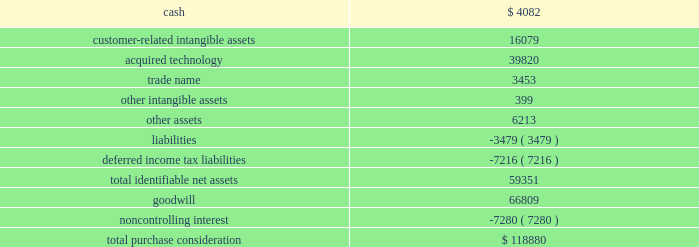Strategy to provide omni-channel solutions that combine gateway services , payment service provisioning and merchant acquiring across europe .
This transaction was accounted for as a business combination .
We recorded the assets acquired , liabilities assumed and noncontrolling interest at their estimated fair values as of the acquisition date .
In connection with the acquisition of realex , we paid a transaction-related tax of $ 1.2 million .
Other acquisition costs were not material .
The revenue and earnings of realex for the year ended may 31 , 2015 were not material nor were the historical revenue and earnings of realex material for the purpose of presenting pro forma information for the current or prior-year periods .
The estimated acquisition date fair values of the assets acquired , liabilities assumed and the noncontrolling interest , including a reconciliation to the total purchase consideration , are as follows ( in thousands ) : .
Goodwill of $ 66.8 million arising from the acquisition , included in the europe segment , was attributable to expected growth opportunities in europe , potential synergies from combining our existing business with gateway services and payment service provisioning in certain markets and an assembled workforce to support the newly acquired technology .
Goodwill associated with this acquisition is not deductible for income tax purposes .
The customer-related intangible assets have an estimated amortization period of 16 years .
The acquired technology has an estimated amortization period of 10 years .
The trade name has an estimated amortization period of 7 years .
On october 5 , 2015 , we paid 20ac6.7 million ( $ 7.5 million equivalent as of october 5 , 2015 ) to acquire the remaining shares of realex after which we own 100% ( 100 % ) of the outstanding shares .
Ezidebit on october 10 , 2014 , we completed the acquisition of 100% ( 100 % ) of the outstanding stock of ezi holdings pty ltd ( 201cezidebit 201d ) for aud302.6 million in cash ( $ 266.0 million equivalent as of the acquisition date ) .
This acquisition was funded by a combination of cash on hand and borrowings on our revolving credit facility .
Ezidebit is a leading integrated payments company focused on recurring payments verticals in australia and new zealand .
Ezidebit markets its services through a network of integrated software vendors and direct channels to numerous vertical markets .
We acquired ezidebit to establish a direct distribution channel in australia and new zealand and to further enhance our existing integrated solutions offerings .
This transaction was accounted for as a business combination .
We recorded the assets acquired and liabilities assumed at their estimated fair values as of the acquisition date .
Certain adjustments to estimated fair value were recorded during the year ended may 31 , 2016 based on new information obtained that existed as of the acquisition date .
During the measurement period , management determined that deferred income taxes should be reflected for certain nondeductible intangible assets .
Measurement-period adjustments , which are reflected in the table below , had no material effect on earnings or other comprehensive income for the current or prior periods .
The revenue and earnings of ezidebit global payments inc .
| 2016 form 10-k annual report 2013 69 .
What percentage of the total purchase consideration is comprised of intangible assets? 
Computations: ((((16079 + 3453) + 399) + 66809) / 118880)
Answer: 0.72964. 